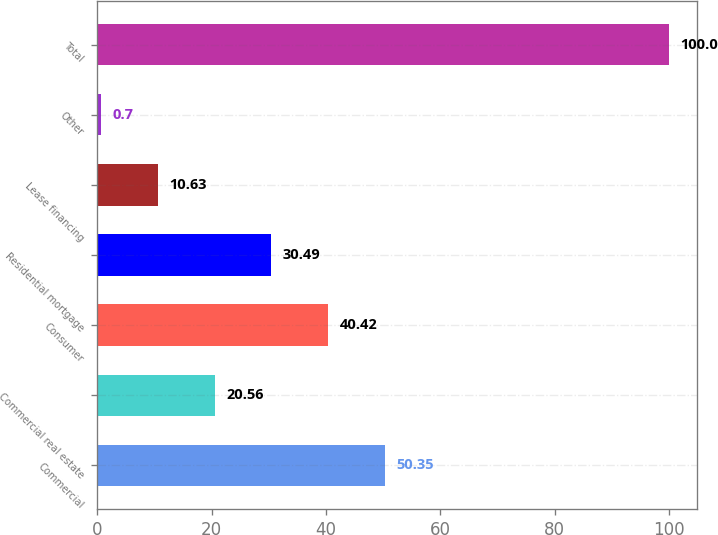Convert chart to OTSL. <chart><loc_0><loc_0><loc_500><loc_500><bar_chart><fcel>Commercial<fcel>Commercial real estate<fcel>Consumer<fcel>Residential mortgage<fcel>Lease financing<fcel>Other<fcel>Total<nl><fcel>50.35<fcel>20.56<fcel>40.42<fcel>30.49<fcel>10.63<fcel>0.7<fcel>100<nl></chart> 